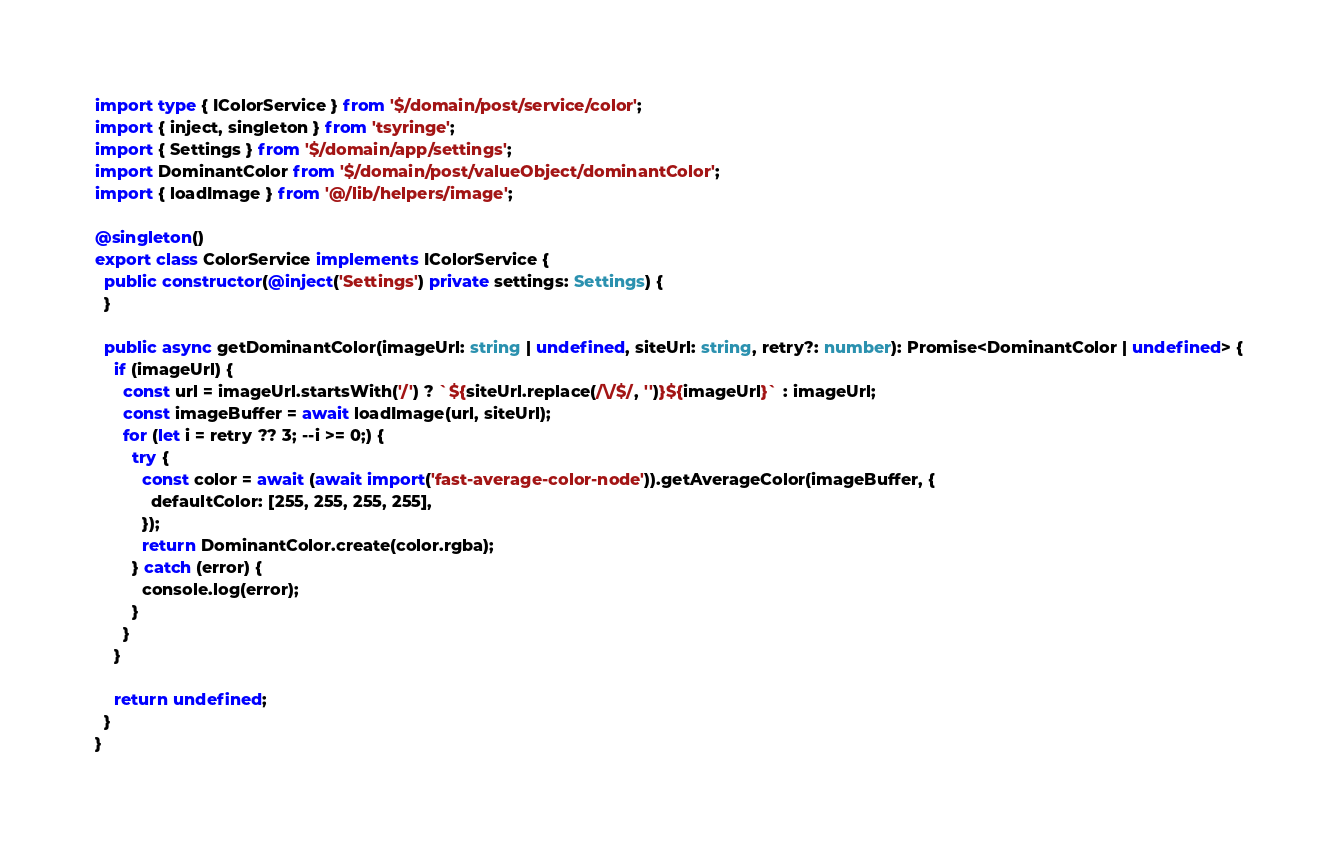Convert code to text. <code><loc_0><loc_0><loc_500><loc_500><_TypeScript_>import type { IColorService } from '$/domain/post/service/color';
import { inject, singleton } from 'tsyringe';
import { Settings } from '$/domain/app/settings';
import DominantColor from '$/domain/post/valueObject/dominantColor';
import { loadImage } from '@/lib/helpers/image';

@singleton()
export class ColorService implements IColorService {
  public constructor(@inject('Settings') private settings: Settings) {
  }

  public async getDominantColor(imageUrl: string | undefined, siteUrl: string, retry?: number): Promise<DominantColor | undefined> {
    if (imageUrl) {
      const url = imageUrl.startsWith('/') ? `${siteUrl.replace(/\/$/, '')}${imageUrl}` : imageUrl;
      const imageBuffer = await loadImage(url, siteUrl);
      for (let i = retry ?? 3; --i >= 0;) {
        try {
          const color = await (await import('fast-average-color-node')).getAverageColor(imageBuffer, {
            defaultColor: [255, 255, 255, 255],
          });
          return DominantColor.create(color.rgba);
        } catch (error) {
          console.log(error);
        }
      }
    }

    return undefined;
  }
}
</code> 